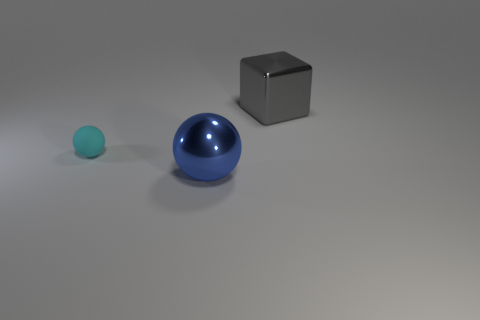What shape is the thing that is left of the gray shiny cube and behind the shiny ball?
Give a very brief answer. Sphere. What is the material of the big thing that is to the left of the big gray object?
Give a very brief answer. Metal. Is the size of the blue sphere the same as the gray metallic cube?
Provide a succinct answer. Yes. Are there more objects that are in front of the big gray thing than red metallic things?
Your answer should be very brief. Yes. There is a blue sphere that is made of the same material as the large gray block; what size is it?
Make the answer very short. Large. Are there any large metallic objects to the left of the cyan rubber ball?
Provide a succinct answer. No. Is the gray metal thing the same shape as the blue object?
Offer a terse response. No. There is a metal object that is left of the big object that is to the right of the shiny thing left of the gray block; what size is it?
Your answer should be very brief. Large. What material is the big gray object?
Keep it short and to the point. Metal. Is the shape of the gray object the same as the large metal thing in front of the small cyan object?
Ensure brevity in your answer.  No. 